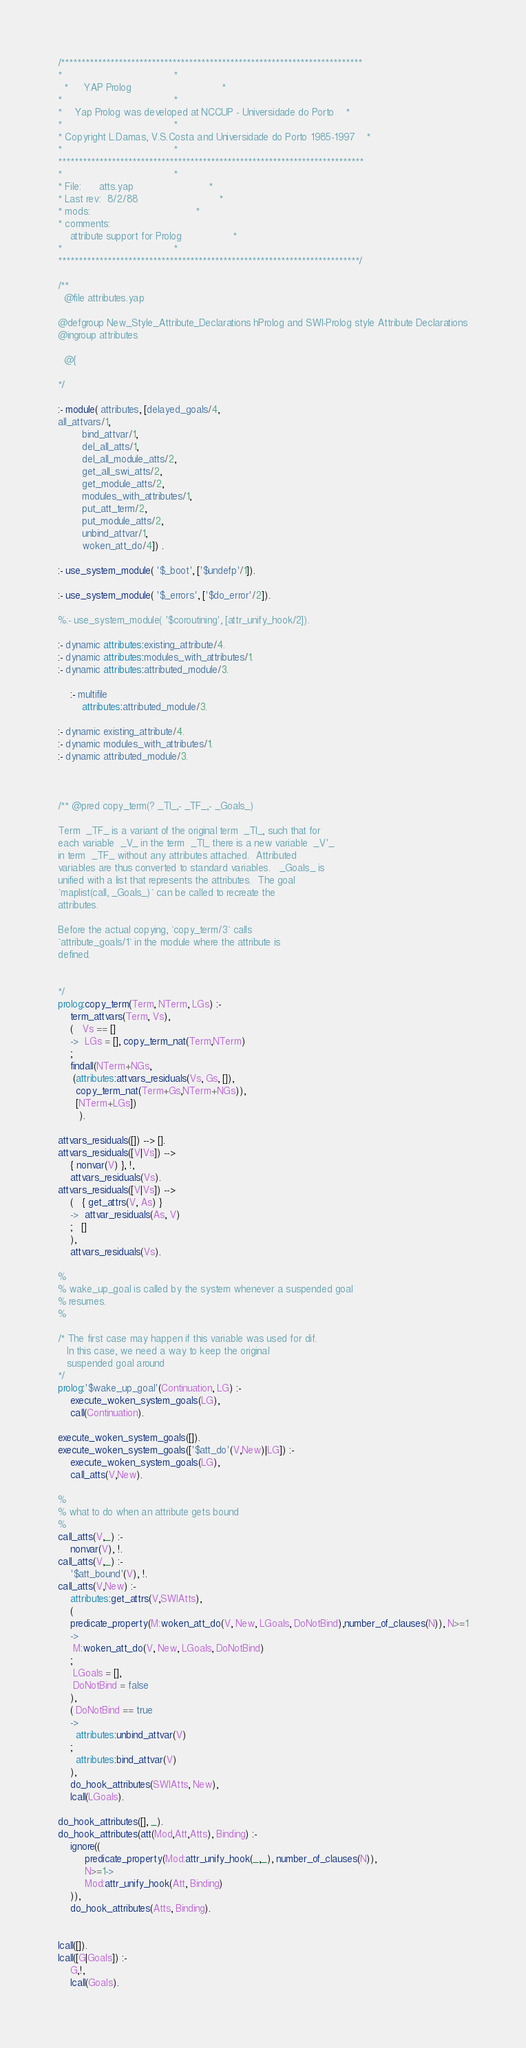Convert code to text. <code><loc_0><loc_0><loc_500><loc_500><_Prolog_>/*************************************************************************
*									 *
  *	 YAP Prolog 							 *
*									 *
*	Yap Prolog was developed at NCCUP - Universidade do Porto	 *
*									 *
* Copyright L.Damas, V.S.Costa and Universidade do Porto 1985-1997	 *
*									 *
**************************************************************************
*									 *
* File:		atts.yap						 *
* Last rev:	8/2/88							 *
* mods:									 *
* comments:
	attribute support for Prolog				 *
*									 *
*************************************************************************/

/**
  @file attributes.yap

@defgroup New_Style_Attribute_Declarations hProlog and SWI-Prolog style Attribute Declarations
@ingroup attributes

  @{

*/

:- module( attributes, [delayed_goals/4,
all_attvars/1,
        bind_attvar/1,
        del_all_atts/1,
        del_all_module_atts/2,
        get_all_swi_atts/2,
        get_module_atts/2,
        modules_with_attributes/1,
        put_att_term/2,
        put_module_atts/2,
        unbind_attvar/1,
        woken_att_do/4]) .

:- use_system_module( '$_boot', ['$undefp'/1]).

:- use_system_module( '$_errors', ['$do_error'/2]).

%:- use_system_module( '$coroutining', [attr_unify_hook/2]).

:- dynamic attributes:existing_attribute/4.
:- dynamic attributes:modules_with_attributes/1.
:- dynamic attributes:attributed_module/3.

    :- multifile
        attributes:attributed_module/3.

:- dynamic existing_attribute/4.
:- dynamic modules_with_attributes/1.
:- dynamic attributed_module/3.



/** @pred copy_term(? _TI_,- _TF_,- _Goals_)

Term  _TF_ is a variant of the original term  _TI_, such that for
each variable  _V_ in the term  _TI_ there is a new variable  _V'_
in term  _TF_ without any attributes attached.  Attributed
variables are thus converted to standard variables.   _Goals_ is
unified with a list that represents the attributes.  The goal
`maplist(call, _Goals_)` can be called to recreate the
attributes.

Before the actual copying, `copy_term/3` calls
`attribute_goals/1` in the module where the attribute is
defined.


*/
prolog:copy_term(Term, NTerm, LGs) :-
	term_attvars(Term, Vs),
	(   Vs == []
	->  LGs = [], copy_term_nat(Term,NTerm)
	;
	findall(NTerm+NGs,
	 (attributes:attvars_residuals(Vs, Gs, []),
	  copy_term_nat(Term+Gs,NTerm+NGs)),
	  [NTerm+LGs])
	   ).

attvars_residuals([]) --> [].
attvars_residuals([V|Vs]) -->
	{ nonvar(V) }, !,
	attvars_residuals(Vs).
attvars_residuals([V|Vs]) -->
	(   { get_attrs(V, As) }
	->  attvar_residuals(As, V)
	;   []
	),
	attvars_residuals(Vs).

%
% wake_up_goal is called by the system whenever a suspended goal
% resumes.
%

/* The first case may happen if this variable was used for dif.
   In this case, we need a way to keep the original
   suspended goal around
*/
prolog:'$wake_up_goal'(Continuation, LG) :-
    execute_woken_system_goals(LG),
    call(Continuation).

execute_woken_system_goals([]).
execute_woken_system_goals(['$att_do'(V,New)|LG]) :-
	execute_woken_system_goals(LG),
	call_atts(V,New).

%
% what to do when an attribute gets bound
%
call_atts(V,_) :-
	nonvar(V), !.
call_atts(V,_) :-
	'$att_bound'(V), !.
call_atts(V,New) :-
    attributes:get_attrs(V,SWIAtts),
    (
	predicate_property(M:woken_att_do(V, New, LGoals, DoNotBind),number_of_clauses(N)), N>=1
	->
	 M:woken_att_do(V, New, LGoals, DoNotBind)
	;
	 LGoals = [],
	 DoNotBind = false
	),
	( DoNotBind == true
	->
	  attributes:unbind_attvar(V)
	;
	  attributes:bind_attvar(V)
	),
	do_hook_attributes(SWIAtts, New),
	lcall(LGoals).

do_hook_attributes([], _).
do_hook_attributes(att(Mod,Att,Atts), Binding) :-
	ignore((
	     predicate_property(Mod:attr_unify_hook(_,_), number_of_clauses(N)),
	     N>=1->
		 Mod:attr_unify_hook(Att, Binding)
	)),
	do_hook_attributes(Atts, Binding).


lcall([]).
lcall([G|Goals]) :-
	G,!,
	lcall(Goals).
</code> 